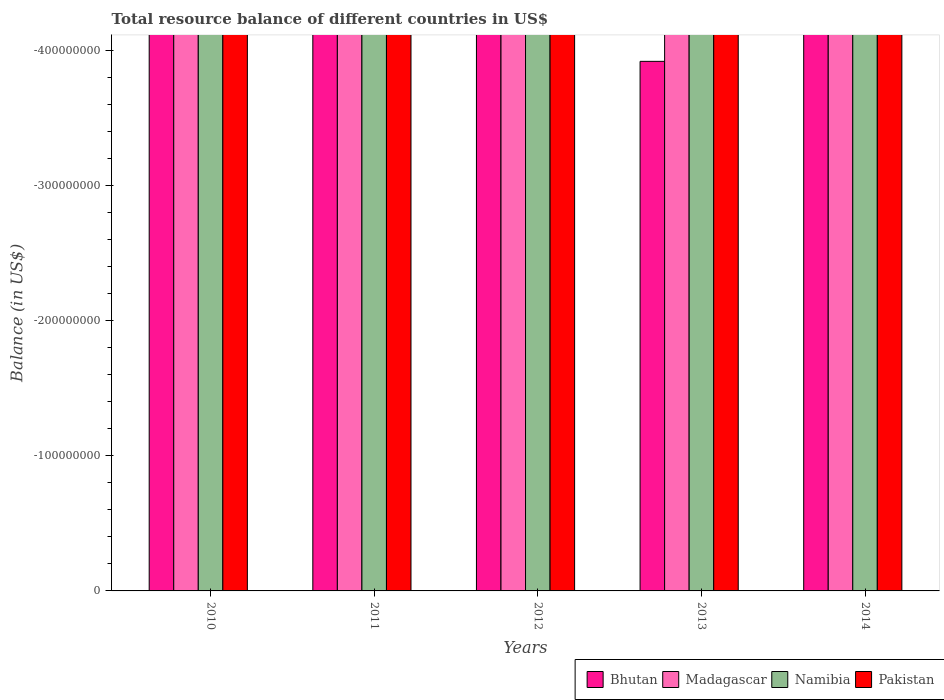How many different coloured bars are there?
Ensure brevity in your answer.  0. What is the label of the 2nd group of bars from the left?
Keep it short and to the point. 2011. What is the total resource balance in Bhutan in 2014?
Your answer should be very brief. 0. What is the total total resource balance in Bhutan in the graph?
Offer a terse response. 0. What is the difference between the total resource balance in Pakistan in 2011 and the total resource balance in Madagascar in 2014?
Provide a short and direct response. 0. What is the average total resource balance in Namibia per year?
Your answer should be compact. 0. In how many years, is the total resource balance in Bhutan greater than the average total resource balance in Bhutan taken over all years?
Make the answer very short. 0. Is it the case that in every year, the sum of the total resource balance in Namibia and total resource balance in Bhutan is greater than the sum of total resource balance in Pakistan and total resource balance in Madagascar?
Your answer should be compact. No. How many bars are there?
Keep it short and to the point. 0. How many years are there in the graph?
Provide a succinct answer. 5. Are the values on the major ticks of Y-axis written in scientific E-notation?
Your answer should be very brief. No. Does the graph contain grids?
Your answer should be very brief. No. Where does the legend appear in the graph?
Make the answer very short. Bottom right. What is the title of the graph?
Provide a succinct answer. Total resource balance of different countries in US$. Does "Albania" appear as one of the legend labels in the graph?
Make the answer very short. No. What is the label or title of the Y-axis?
Give a very brief answer. Balance (in US$). What is the Balance (in US$) in Madagascar in 2010?
Your response must be concise. 0. What is the Balance (in US$) of Namibia in 2010?
Your response must be concise. 0. What is the Balance (in US$) of Pakistan in 2010?
Your response must be concise. 0. What is the Balance (in US$) in Madagascar in 2011?
Make the answer very short. 0. What is the Balance (in US$) in Pakistan in 2011?
Offer a very short reply. 0. What is the Balance (in US$) of Bhutan in 2012?
Provide a succinct answer. 0. What is the Balance (in US$) in Pakistan in 2012?
Make the answer very short. 0. What is the Balance (in US$) of Pakistan in 2013?
Your response must be concise. 0. What is the Balance (in US$) in Madagascar in 2014?
Make the answer very short. 0. What is the total Balance (in US$) of Madagascar in the graph?
Your response must be concise. 0. What is the total Balance (in US$) of Pakistan in the graph?
Offer a very short reply. 0. What is the average Balance (in US$) of Namibia per year?
Ensure brevity in your answer.  0. 